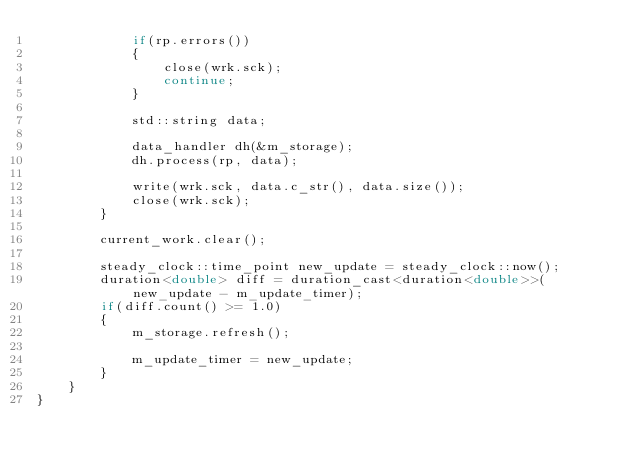Convert code to text. <code><loc_0><loc_0><loc_500><loc_500><_C++_>            if(rp.errors())
            {
                close(wrk.sck);
                continue;
            }
            
            std::string data;
            
            data_handler dh(&m_storage);
            dh.process(rp, data);

            write(wrk.sck, data.c_str(), data.size());
            close(wrk.sck);
        }
        
        current_work.clear();
        
        steady_clock::time_point new_update = steady_clock::now();
        duration<double> diff = duration_cast<duration<double>>(new_update - m_update_timer);
        if(diff.count() >= 1.0)
        {
            m_storage.refresh();
            
            m_update_timer = new_update;
        }
    }
}
</code> 